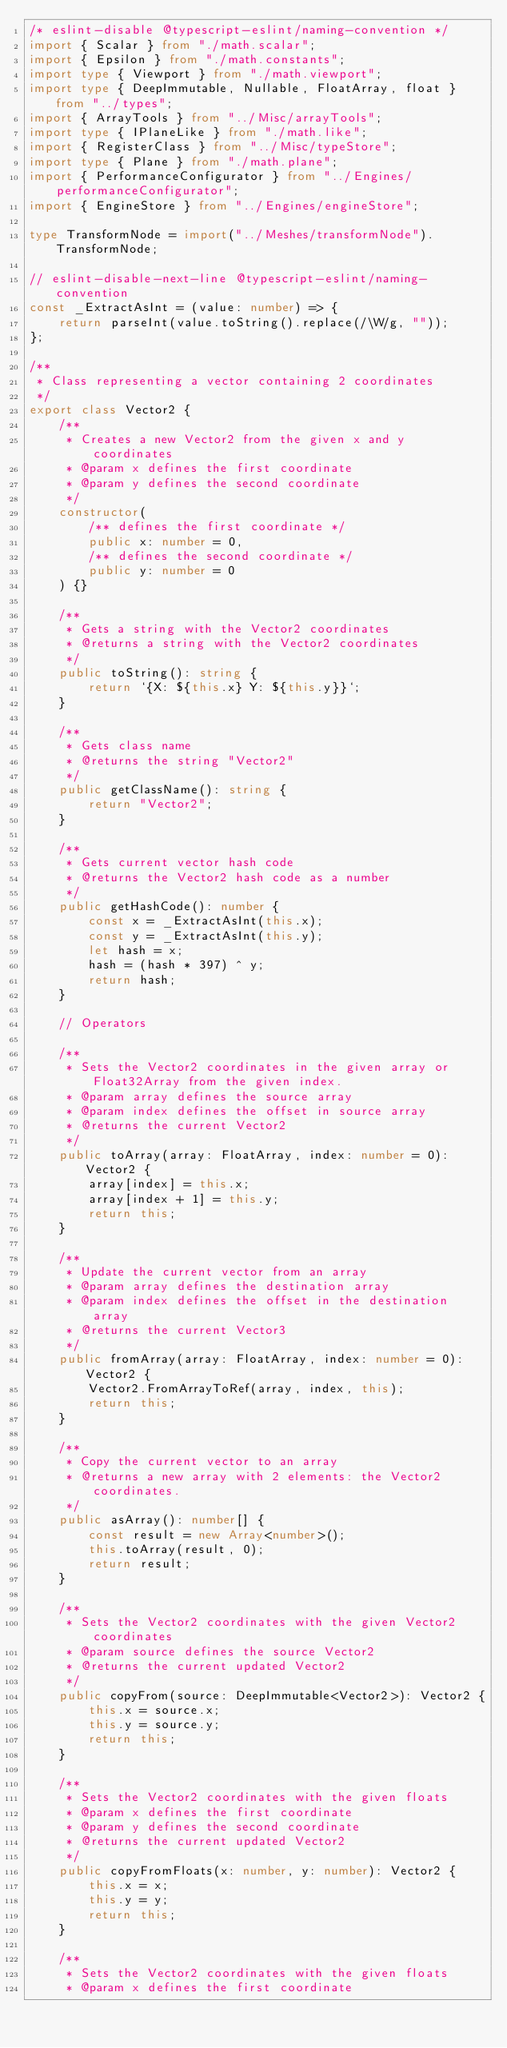Convert code to text. <code><loc_0><loc_0><loc_500><loc_500><_TypeScript_>/* eslint-disable @typescript-eslint/naming-convention */
import { Scalar } from "./math.scalar";
import { Epsilon } from "./math.constants";
import type { Viewport } from "./math.viewport";
import type { DeepImmutable, Nullable, FloatArray, float } from "../types";
import { ArrayTools } from "../Misc/arrayTools";
import type { IPlaneLike } from "./math.like";
import { RegisterClass } from "../Misc/typeStore";
import type { Plane } from "./math.plane";
import { PerformanceConfigurator } from "../Engines/performanceConfigurator";
import { EngineStore } from "../Engines/engineStore";

type TransformNode = import("../Meshes/transformNode").TransformNode;

// eslint-disable-next-line @typescript-eslint/naming-convention
const _ExtractAsInt = (value: number) => {
    return parseInt(value.toString().replace(/\W/g, ""));
};

/**
 * Class representing a vector containing 2 coordinates
 */
export class Vector2 {
    /**
     * Creates a new Vector2 from the given x and y coordinates
     * @param x defines the first coordinate
     * @param y defines the second coordinate
     */
    constructor(
        /** defines the first coordinate */
        public x: number = 0,
        /** defines the second coordinate */
        public y: number = 0
    ) {}

    /**
     * Gets a string with the Vector2 coordinates
     * @returns a string with the Vector2 coordinates
     */
    public toString(): string {
        return `{X: ${this.x} Y: ${this.y}}`;
    }

    /**
     * Gets class name
     * @returns the string "Vector2"
     */
    public getClassName(): string {
        return "Vector2";
    }

    /**
     * Gets current vector hash code
     * @returns the Vector2 hash code as a number
     */
    public getHashCode(): number {
        const x = _ExtractAsInt(this.x);
        const y = _ExtractAsInt(this.y);
        let hash = x;
        hash = (hash * 397) ^ y;
        return hash;
    }

    // Operators

    /**
     * Sets the Vector2 coordinates in the given array or Float32Array from the given index.
     * @param array defines the source array
     * @param index defines the offset in source array
     * @returns the current Vector2
     */
    public toArray(array: FloatArray, index: number = 0): Vector2 {
        array[index] = this.x;
        array[index + 1] = this.y;
        return this;
    }

    /**
     * Update the current vector from an array
     * @param array defines the destination array
     * @param index defines the offset in the destination array
     * @returns the current Vector3
     */
    public fromArray(array: FloatArray, index: number = 0): Vector2 {
        Vector2.FromArrayToRef(array, index, this);
        return this;
    }

    /**
     * Copy the current vector to an array
     * @returns a new array with 2 elements: the Vector2 coordinates.
     */
    public asArray(): number[] {
        const result = new Array<number>();
        this.toArray(result, 0);
        return result;
    }

    /**
     * Sets the Vector2 coordinates with the given Vector2 coordinates
     * @param source defines the source Vector2
     * @returns the current updated Vector2
     */
    public copyFrom(source: DeepImmutable<Vector2>): Vector2 {
        this.x = source.x;
        this.y = source.y;
        return this;
    }

    /**
     * Sets the Vector2 coordinates with the given floats
     * @param x defines the first coordinate
     * @param y defines the second coordinate
     * @returns the current updated Vector2
     */
    public copyFromFloats(x: number, y: number): Vector2 {
        this.x = x;
        this.y = y;
        return this;
    }

    /**
     * Sets the Vector2 coordinates with the given floats
     * @param x defines the first coordinate</code> 